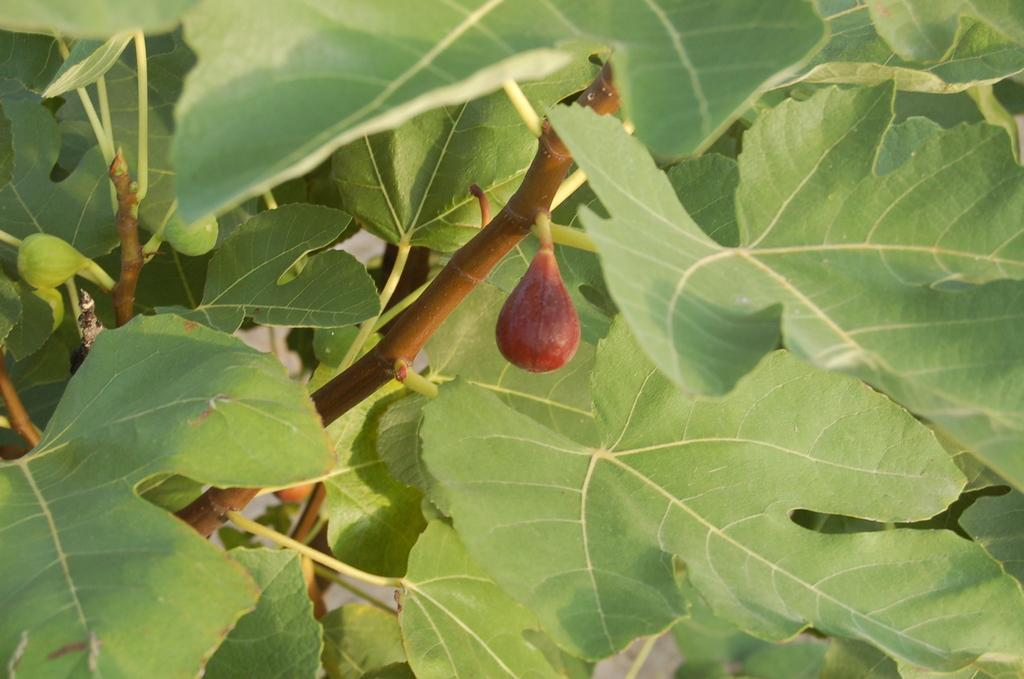What is present on the branches of the tree in the image? There are fruits and leaves on the branches of the tree in the image. Can you describe the type of vegetation in the image? The image features a tree with fruits and leaves on its branches. What month is it in the image? The month is not mentioned or depicted in the image, so it cannot be determined. 